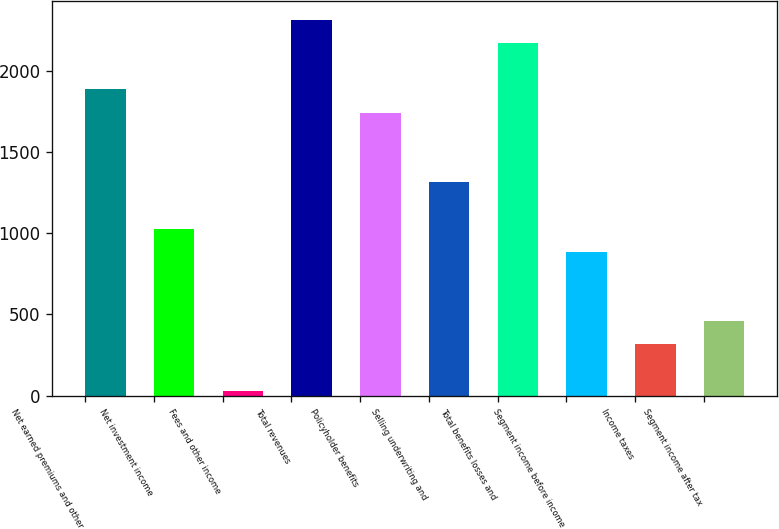Convert chart. <chart><loc_0><loc_0><loc_500><loc_500><bar_chart><fcel>Net earned premiums and other<fcel>Net investment income<fcel>Fees and other income<fcel>Total revenues<fcel>Policyholder benefits<fcel>Selling underwriting and<fcel>Total benefits losses and<fcel>Segment income before income<fcel>Income taxes<fcel>Segment income after tax<nl><fcel>1884.1<fcel>1027.9<fcel>29<fcel>2312.2<fcel>1741.4<fcel>1313.3<fcel>2169.5<fcel>885.2<fcel>314.4<fcel>457.1<nl></chart> 